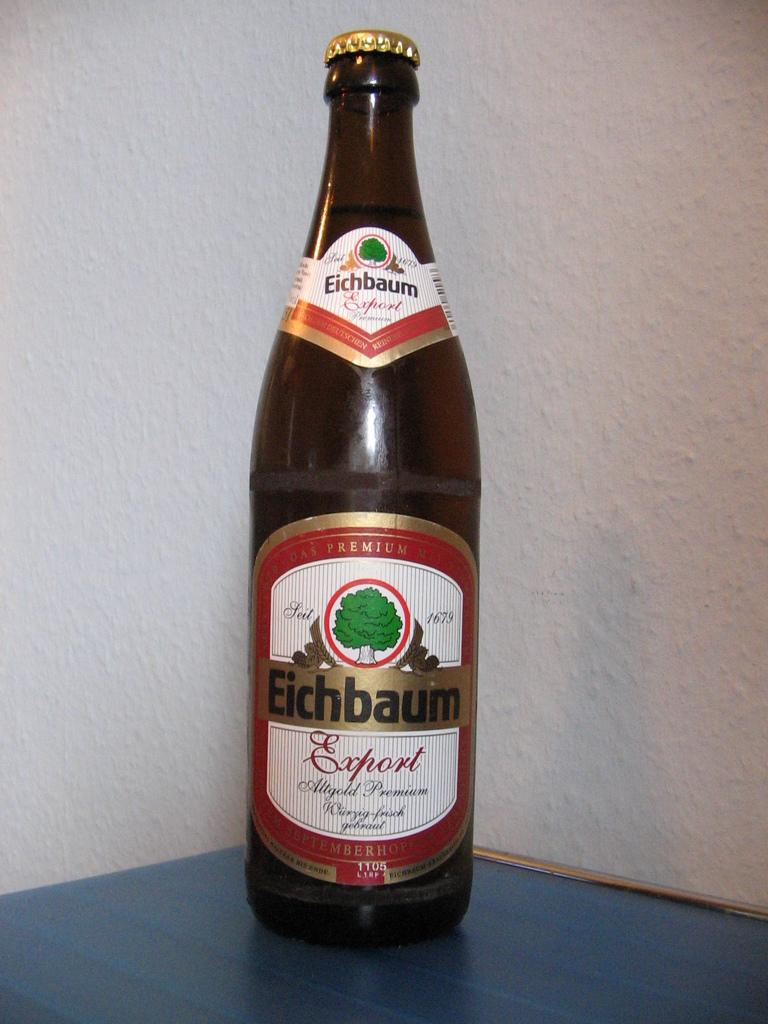<image>
Describe the image concisely. a bottle of eichbaum export  with a white and red label on it 